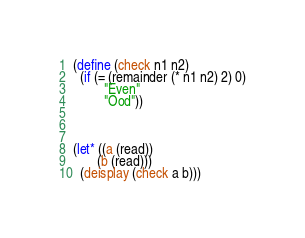<code> <loc_0><loc_0><loc_500><loc_500><_Scheme_>(define (check n1 n2)
  (if (= (remainder (* n1 n2) 2) 0)
         "Even"
         "Ood"))
 
 
 
(let* ((a (read))
       (b (read)))
  (deisplay (check a b)))</code> 